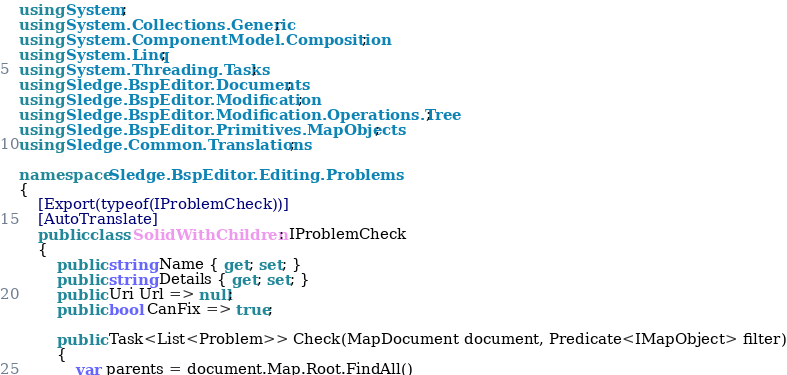<code> <loc_0><loc_0><loc_500><loc_500><_C#_>using System;
using System.Collections.Generic;
using System.ComponentModel.Composition;
using System.Linq;
using System.Threading.Tasks;
using Sledge.BspEditor.Documents;
using Sledge.BspEditor.Modification;
using Sledge.BspEditor.Modification.Operations.Tree;
using Sledge.BspEditor.Primitives.MapObjects;
using Sledge.Common.Translations;

namespace Sledge.BspEditor.Editing.Problems
{
    [Export(typeof(IProblemCheck))]
    [AutoTranslate]
    public class SolidWithChildren : IProblemCheck
    {
        public string Name { get; set; }
        public string Details { get; set; }
        public Uri Url => null;
        public bool CanFix => true;

        public Task<List<Problem>> Check(MapDocument document, Predicate<IMapObject> filter)
        {
            var parents = document.Map.Root.FindAll()</code> 